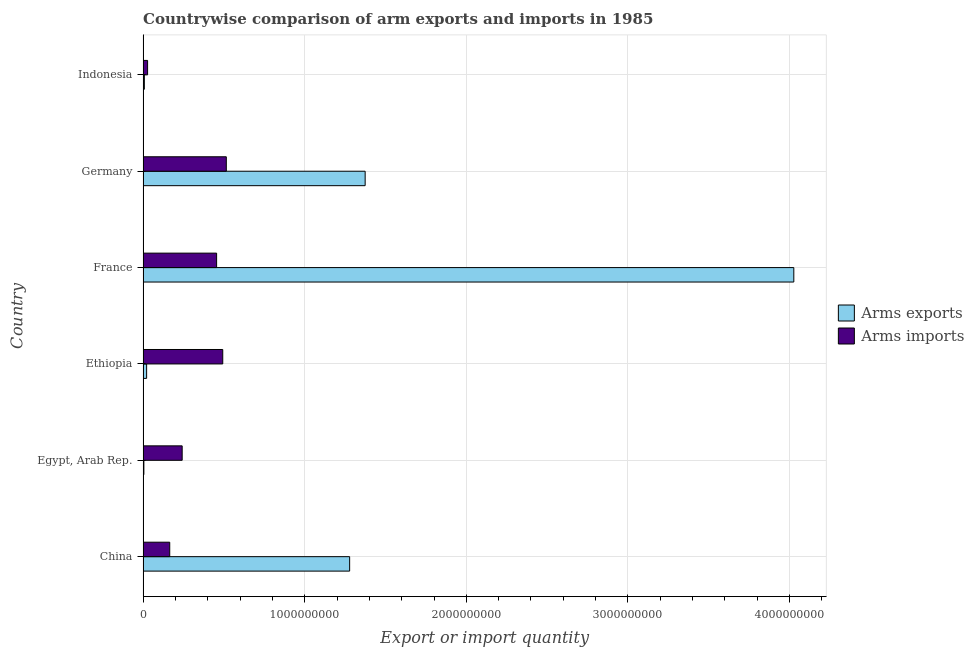Are the number of bars on each tick of the Y-axis equal?
Give a very brief answer. Yes. In how many cases, is the number of bars for a given country not equal to the number of legend labels?
Provide a succinct answer. 0. What is the arms imports in Indonesia?
Your answer should be compact. 2.80e+07. Across all countries, what is the maximum arms exports?
Keep it short and to the point. 4.03e+09. Across all countries, what is the minimum arms exports?
Keep it short and to the point. 5.00e+06. In which country was the arms imports minimum?
Give a very brief answer. Indonesia. What is the total arms imports in the graph?
Keep it short and to the point. 1.90e+09. What is the difference between the arms exports in France and that in Indonesia?
Ensure brevity in your answer.  4.02e+09. What is the difference between the arms imports in Egypt, Arab Rep. and the arms exports in France?
Offer a terse response. -3.78e+09. What is the average arms exports per country?
Give a very brief answer. 1.12e+09. What is the difference between the arms imports and arms exports in Germany?
Give a very brief answer. -8.59e+08. What is the ratio of the arms imports in France to that in Germany?
Provide a succinct answer. 0.88. Is the arms imports in China less than that in Germany?
Your answer should be very brief. Yes. What is the difference between the highest and the second highest arms imports?
Offer a very short reply. 2.20e+07. What is the difference between the highest and the lowest arms imports?
Keep it short and to the point. 4.87e+08. In how many countries, is the arms exports greater than the average arms exports taken over all countries?
Provide a short and direct response. 3. Is the sum of the arms imports in France and Indonesia greater than the maximum arms exports across all countries?
Provide a short and direct response. No. What does the 2nd bar from the top in China represents?
Offer a very short reply. Arms exports. What does the 1st bar from the bottom in Ethiopia represents?
Make the answer very short. Arms exports. Are all the bars in the graph horizontal?
Your answer should be very brief. Yes. Does the graph contain any zero values?
Provide a succinct answer. No. Where does the legend appear in the graph?
Ensure brevity in your answer.  Center right. How are the legend labels stacked?
Provide a short and direct response. Vertical. What is the title of the graph?
Your answer should be very brief. Countrywise comparison of arm exports and imports in 1985. Does "Lower secondary education" appear as one of the legend labels in the graph?
Your response must be concise. No. What is the label or title of the X-axis?
Ensure brevity in your answer.  Export or import quantity. What is the Export or import quantity in Arms exports in China?
Ensure brevity in your answer.  1.28e+09. What is the Export or import quantity of Arms imports in China?
Make the answer very short. 1.65e+08. What is the Export or import quantity of Arms exports in Egypt, Arab Rep.?
Your answer should be very brief. 5.00e+06. What is the Export or import quantity in Arms imports in Egypt, Arab Rep.?
Provide a short and direct response. 2.42e+08. What is the Export or import quantity in Arms exports in Ethiopia?
Make the answer very short. 2.20e+07. What is the Export or import quantity of Arms imports in Ethiopia?
Provide a short and direct response. 4.93e+08. What is the Export or import quantity in Arms exports in France?
Your answer should be compact. 4.03e+09. What is the Export or import quantity of Arms imports in France?
Provide a succinct answer. 4.55e+08. What is the Export or import quantity of Arms exports in Germany?
Offer a terse response. 1.37e+09. What is the Export or import quantity in Arms imports in Germany?
Your answer should be compact. 5.15e+08. What is the Export or import quantity in Arms imports in Indonesia?
Your answer should be compact. 2.80e+07. Across all countries, what is the maximum Export or import quantity of Arms exports?
Provide a short and direct response. 4.03e+09. Across all countries, what is the maximum Export or import quantity of Arms imports?
Your response must be concise. 5.15e+08. Across all countries, what is the minimum Export or import quantity of Arms imports?
Ensure brevity in your answer.  2.80e+07. What is the total Export or import quantity in Arms exports in the graph?
Your response must be concise. 6.71e+09. What is the total Export or import quantity in Arms imports in the graph?
Your answer should be compact. 1.90e+09. What is the difference between the Export or import quantity in Arms exports in China and that in Egypt, Arab Rep.?
Provide a short and direct response. 1.27e+09. What is the difference between the Export or import quantity in Arms imports in China and that in Egypt, Arab Rep.?
Keep it short and to the point. -7.70e+07. What is the difference between the Export or import quantity of Arms exports in China and that in Ethiopia?
Your answer should be very brief. 1.26e+09. What is the difference between the Export or import quantity of Arms imports in China and that in Ethiopia?
Ensure brevity in your answer.  -3.28e+08. What is the difference between the Export or import quantity of Arms exports in China and that in France?
Your answer should be compact. -2.75e+09. What is the difference between the Export or import quantity in Arms imports in China and that in France?
Ensure brevity in your answer.  -2.90e+08. What is the difference between the Export or import quantity of Arms exports in China and that in Germany?
Your answer should be compact. -9.60e+07. What is the difference between the Export or import quantity of Arms imports in China and that in Germany?
Ensure brevity in your answer.  -3.50e+08. What is the difference between the Export or import quantity in Arms exports in China and that in Indonesia?
Ensure brevity in your answer.  1.27e+09. What is the difference between the Export or import quantity of Arms imports in China and that in Indonesia?
Offer a terse response. 1.37e+08. What is the difference between the Export or import quantity in Arms exports in Egypt, Arab Rep. and that in Ethiopia?
Keep it short and to the point. -1.70e+07. What is the difference between the Export or import quantity of Arms imports in Egypt, Arab Rep. and that in Ethiopia?
Make the answer very short. -2.51e+08. What is the difference between the Export or import quantity in Arms exports in Egypt, Arab Rep. and that in France?
Your response must be concise. -4.02e+09. What is the difference between the Export or import quantity in Arms imports in Egypt, Arab Rep. and that in France?
Make the answer very short. -2.13e+08. What is the difference between the Export or import quantity in Arms exports in Egypt, Arab Rep. and that in Germany?
Your answer should be compact. -1.37e+09. What is the difference between the Export or import quantity in Arms imports in Egypt, Arab Rep. and that in Germany?
Your answer should be very brief. -2.73e+08. What is the difference between the Export or import quantity of Arms imports in Egypt, Arab Rep. and that in Indonesia?
Provide a succinct answer. 2.14e+08. What is the difference between the Export or import quantity of Arms exports in Ethiopia and that in France?
Keep it short and to the point. -4.00e+09. What is the difference between the Export or import quantity of Arms imports in Ethiopia and that in France?
Offer a very short reply. 3.80e+07. What is the difference between the Export or import quantity of Arms exports in Ethiopia and that in Germany?
Your answer should be compact. -1.35e+09. What is the difference between the Export or import quantity of Arms imports in Ethiopia and that in Germany?
Your answer should be very brief. -2.20e+07. What is the difference between the Export or import quantity in Arms exports in Ethiopia and that in Indonesia?
Keep it short and to the point. 1.40e+07. What is the difference between the Export or import quantity of Arms imports in Ethiopia and that in Indonesia?
Your response must be concise. 4.65e+08. What is the difference between the Export or import quantity in Arms exports in France and that in Germany?
Provide a succinct answer. 2.65e+09. What is the difference between the Export or import quantity of Arms imports in France and that in Germany?
Provide a succinct answer. -6.00e+07. What is the difference between the Export or import quantity of Arms exports in France and that in Indonesia?
Provide a short and direct response. 4.02e+09. What is the difference between the Export or import quantity of Arms imports in France and that in Indonesia?
Make the answer very short. 4.27e+08. What is the difference between the Export or import quantity in Arms exports in Germany and that in Indonesia?
Make the answer very short. 1.37e+09. What is the difference between the Export or import quantity in Arms imports in Germany and that in Indonesia?
Give a very brief answer. 4.87e+08. What is the difference between the Export or import quantity in Arms exports in China and the Export or import quantity in Arms imports in Egypt, Arab Rep.?
Offer a very short reply. 1.04e+09. What is the difference between the Export or import quantity in Arms exports in China and the Export or import quantity in Arms imports in Ethiopia?
Provide a succinct answer. 7.85e+08. What is the difference between the Export or import quantity of Arms exports in China and the Export or import quantity of Arms imports in France?
Your answer should be compact. 8.23e+08. What is the difference between the Export or import quantity of Arms exports in China and the Export or import quantity of Arms imports in Germany?
Your answer should be very brief. 7.63e+08. What is the difference between the Export or import quantity of Arms exports in China and the Export or import quantity of Arms imports in Indonesia?
Keep it short and to the point. 1.25e+09. What is the difference between the Export or import quantity in Arms exports in Egypt, Arab Rep. and the Export or import quantity in Arms imports in Ethiopia?
Your response must be concise. -4.88e+08. What is the difference between the Export or import quantity of Arms exports in Egypt, Arab Rep. and the Export or import quantity of Arms imports in France?
Your answer should be very brief. -4.50e+08. What is the difference between the Export or import quantity of Arms exports in Egypt, Arab Rep. and the Export or import quantity of Arms imports in Germany?
Your answer should be very brief. -5.10e+08. What is the difference between the Export or import quantity in Arms exports in Egypt, Arab Rep. and the Export or import quantity in Arms imports in Indonesia?
Provide a succinct answer. -2.30e+07. What is the difference between the Export or import quantity in Arms exports in Ethiopia and the Export or import quantity in Arms imports in France?
Provide a short and direct response. -4.33e+08. What is the difference between the Export or import quantity of Arms exports in Ethiopia and the Export or import quantity of Arms imports in Germany?
Your answer should be compact. -4.93e+08. What is the difference between the Export or import quantity of Arms exports in Ethiopia and the Export or import quantity of Arms imports in Indonesia?
Your response must be concise. -6.00e+06. What is the difference between the Export or import quantity in Arms exports in France and the Export or import quantity in Arms imports in Germany?
Offer a terse response. 3.51e+09. What is the difference between the Export or import quantity in Arms exports in France and the Export or import quantity in Arms imports in Indonesia?
Your answer should be compact. 4.00e+09. What is the difference between the Export or import quantity of Arms exports in Germany and the Export or import quantity of Arms imports in Indonesia?
Your response must be concise. 1.35e+09. What is the average Export or import quantity in Arms exports per country?
Provide a succinct answer. 1.12e+09. What is the average Export or import quantity of Arms imports per country?
Offer a very short reply. 3.16e+08. What is the difference between the Export or import quantity in Arms exports and Export or import quantity in Arms imports in China?
Your answer should be compact. 1.11e+09. What is the difference between the Export or import quantity in Arms exports and Export or import quantity in Arms imports in Egypt, Arab Rep.?
Keep it short and to the point. -2.37e+08. What is the difference between the Export or import quantity of Arms exports and Export or import quantity of Arms imports in Ethiopia?
Make the answer very short. -4.71e+08. What is the difference between the Export or import quantity in Arms exports and Export or import quantity in Arms imports in France?
Give a very brief answer. 3.57e+09. What is the difference between the Export or import quantity in Arms exports and Export or import quantity in Arms imports in Germany?
Provide a succinct answer. 8.59e+08. What is the difference between the Export or import quantity in Arms exports and Export or import quantity in Arms imports in Indonesia?
Keep it short and to the point. -2.00e+07. What is the ratio of the Export or import quantity of Arms exports in China to that in Egypt, Arab Rep.?
Your answer should be compact. 255.6. What is the ratio of the Export or import quantity in Arms imports in China to that in Egypt, Arab Rep.?
Keep it short and to the point. 0.68. What is the ratio of the Export or import quantity of Arms exports in China to that in Ethiopia?
Give a very brief answer. 58.09. What is the ratio of the Export or import quantity in Arms imports in China to that in Ethiopia?
Give a very brief answer. 0.33. What is the ratio of the Export or import quantity in Arms exports in China to that in France?
Provide a succinct answer. 0.32. What is the ratio of the Export or import quantity of Arms imports in China to that in France?
Ensure brevity in your answer.  0.36. What is the ratio of the Export or import quantity in Arms exports in China to that in Germany?
Keep it short and to the point. 0.93. What is the ratio of the Export or import quantity in Arms imports in China to that in Germany?
Provide a succinct answer. 0.32. What is the ratio of the Export or import quantity in Arms exports in China to that in Indonesia?
Give a very brief answer. 159.75. What is the ratio of the Export or import quantity in Arms imports in China to that in Indonesia?
Ensure brevity in your answer.  5.89. What is the ratio of the Export or import quantity of Arms exports in Egypt, Arab Rep. to that in Ethiopia?
Offer a very short reply. 0.23. What is the ratio of the Export or import quantity in Arms imports in Egypt, Arab Rep. to that in Ethiopia?
Your answer should be compact. 0.49. What is the ratio of the Export or import quantity of Arms exports in Egypt, Arab Rep. to that in France?
Your answer should be compact. 0. What is the ratio of the Export or import quantity in Arms imports in Egypt, Arab Rep. to that in France?
Your answer should be very brief. 0.53. What is the ratio of the Export or import quantity in Arms exports in Egypt, Arab Rep. to that in Germany?
Provide a succinct answer. 0. What is the ratio of the Export or import quantity in Arms imports in Egypt, Arab Rep. to that in Germany?
Give a very brief answer. 0.47. What is the ratio of the Export or import quantity of Arms exports in Egypt, Arab Rep. to that in Indonesia?
Your answer should be very brief. 0.62. What is the ratio of the Export or import quantity of Arms imports in Egypt, Arab Rep. to that in Indonesia?
Offer a terse response. 8.64. What is the ratio of the Export or import quantity of Arms exports in Ethiopia to that in France?
Your answer should be compact. 0.01. What is the ratio of the Export or import quantity of Arms imports in Ethiopia to that in France?
Provide a short and direct response. 1.08. What is the ratio of the Export or import quantity of Arms exports in Ethiopia to that in Germany?
Provide a short and direct response. 0.02. What is the ratio of the Export or import quantity in Arms imports in Ethiopia to that in Germany?
Provide a succinct answer. 0.96. What is the ratio of the Export or import quantity of Arms exports in Ethiopia to that in Indonesia?
Provide a succinct answer. 2.75. What is the ratio of the Export or import quantity in Arms imports in Ethiopia to that in Indonesia?
Your answer should be very brief. 17.61. What is the ratio of the Export or import quantity of Arms exports in France to that in Germany?
Provide a short and direct response. 2.93. What is the ratio of the Export or import quantity in Arms imports in France to that in Germany?
Provide a short and direct response. 0.88. What is the ratio of the Export or import quantity in Arms exports in France to that in Indonesia?
Offer a terse response. 503.25. What is the ratio of the Export or import quantity in Arms imports in France to that in Indonesia?
Your response must be concise. 16.25. What is the ratio of the Export or import quantity of Arms exports in Germany to that in Indonesia?
Your response must be concise. 171.75. What is the ratio of the Export or import quantity of Arms imports in Germany to that in Indonesia?
Keep it short and to the point. 18.39. What is the difference between the highest and the second highest Export or import quantity in Arms exports?
Your answer should be very brief. 2.65e+09. What is the difference between the highest and the second highest Export or import quantity in Arms imports?
Make the answer very short. 2.20e+07. What is the difference between the highest and the lowest Export or import quantity of Arms exports?
Ensure brevity in your answer.  4.02e+09. What is the difference between the highest and the lowest Export or import quantity in Arms imports?
Ensure brevity in your answer.  4.87e+08. 